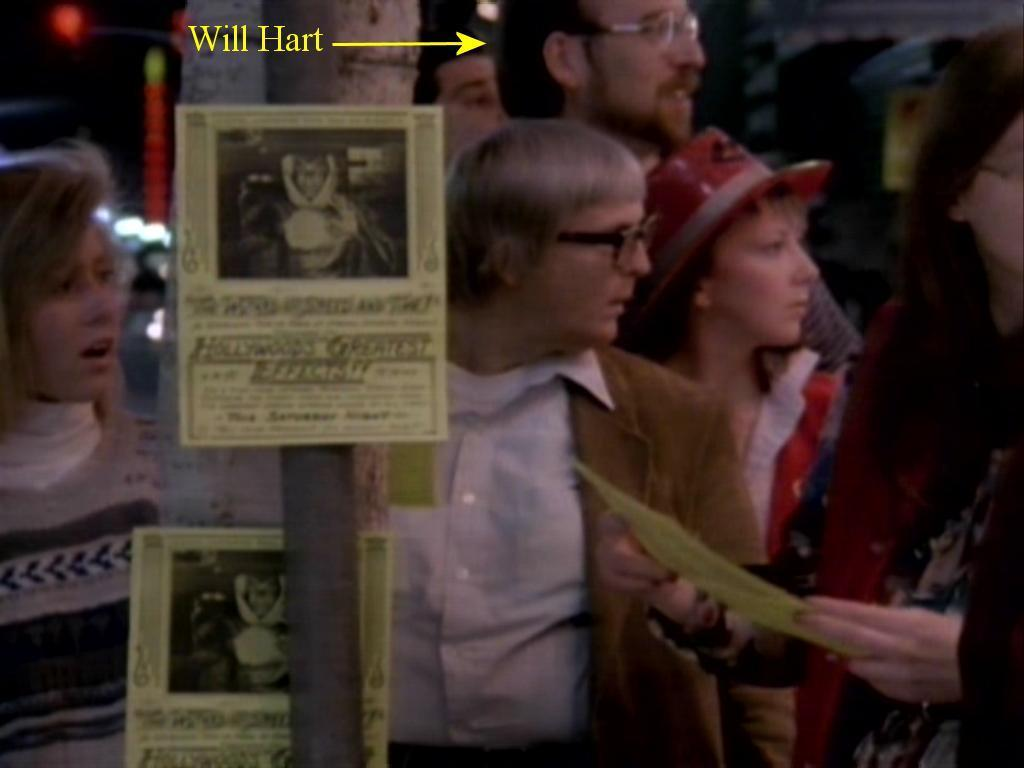What is the main structure in the image? There is a pole with boards in the image. Are there any people present in the image? Yes, there are people standing behind the pole. What direction are the people looking? The people are looking to the right side. What type of rake is being used by the people in the image? There is no rake present in the image; the people are standing behind a pole with boards. 